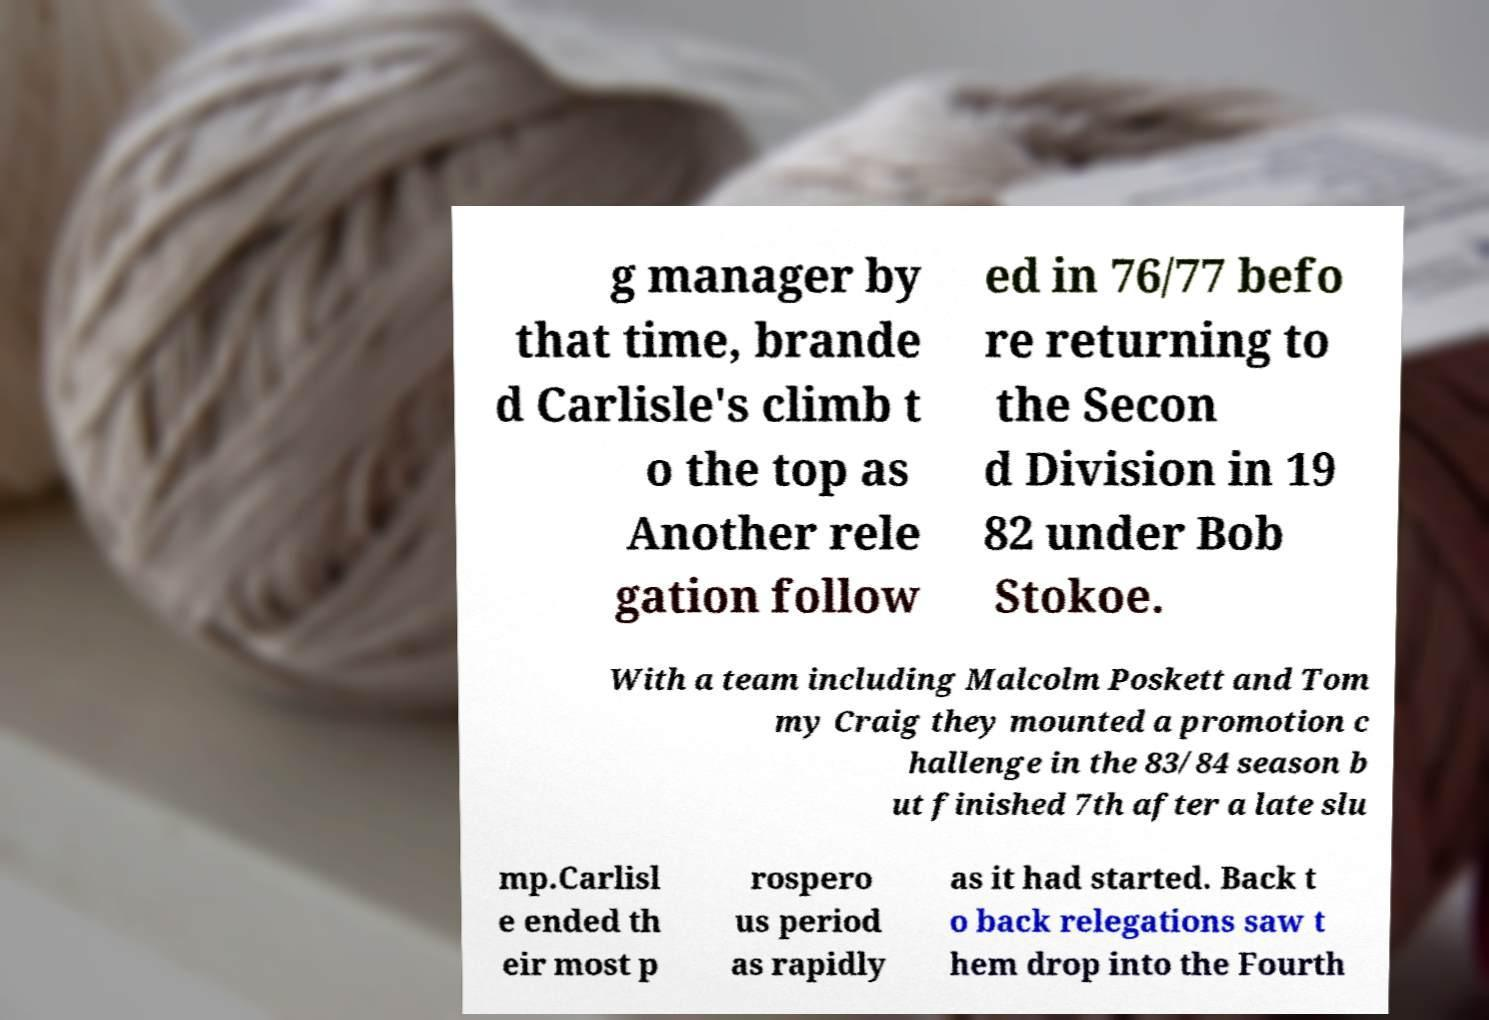Can you read and provide the text displayed in the image?This photo seems to have some interesting text. Can you extract and type it out for me? g manager by that time, brande d Carlisle's climb t o the top as Another rele gation follow ed in 76/77 befo re returning to the Secon d Division in 19 82 under Bob Stokoe. With a team including Malcolm Poskett and Tom my Craig they mounted a promotion c hallenge in the 83/84 season b ut finished 7th after a late slu mp.Carlisl e ended th eir most p rospero us period as rapidly as it had started. Back t o back relegations saw t hem drop into the Fourth 